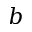<formula> <loc_0><loc_0><loc_500><loc_500>b</formula> 